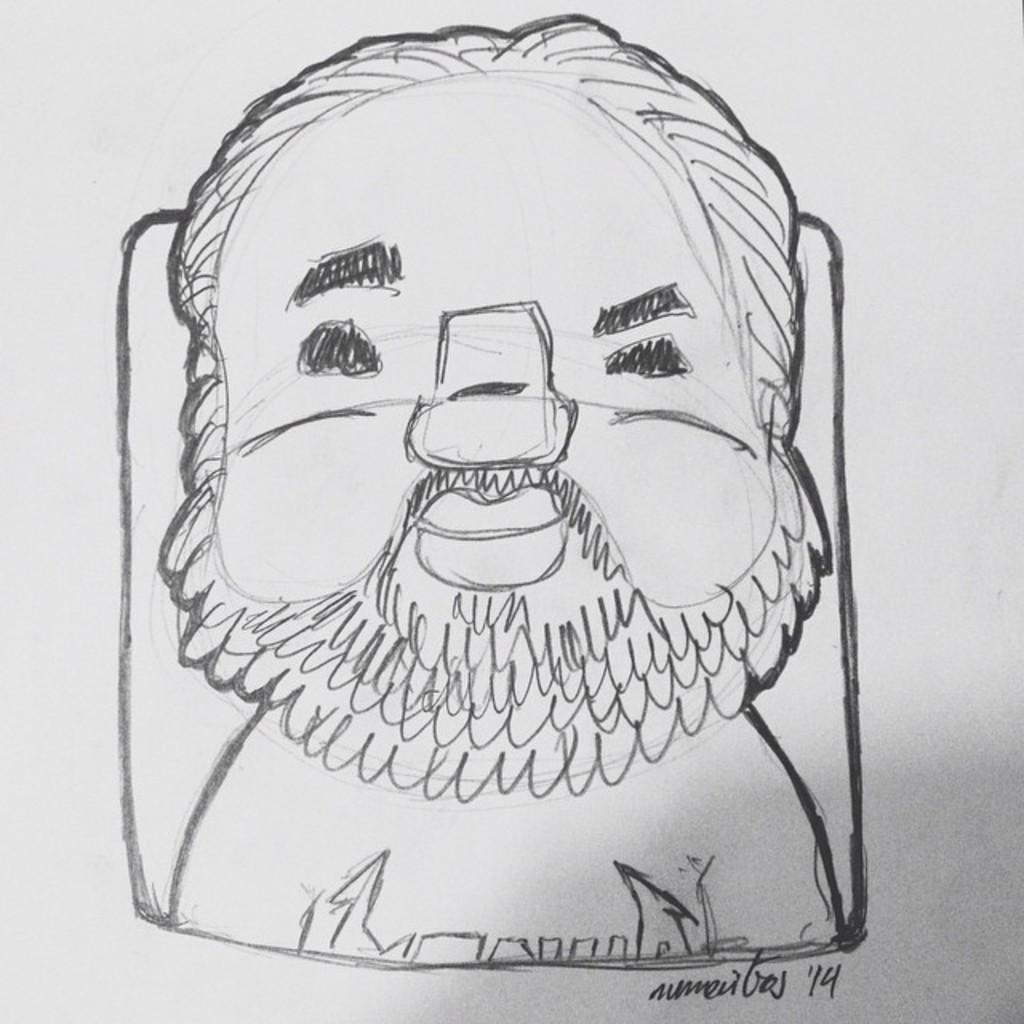What is depicted in the image? There is a drawing of a person in the image. What type of reaction can be seen from the person at the seashore during the camp? There is no seashore, camp, or person's reaction depicted in the image, as it only features a drawing of a person. 